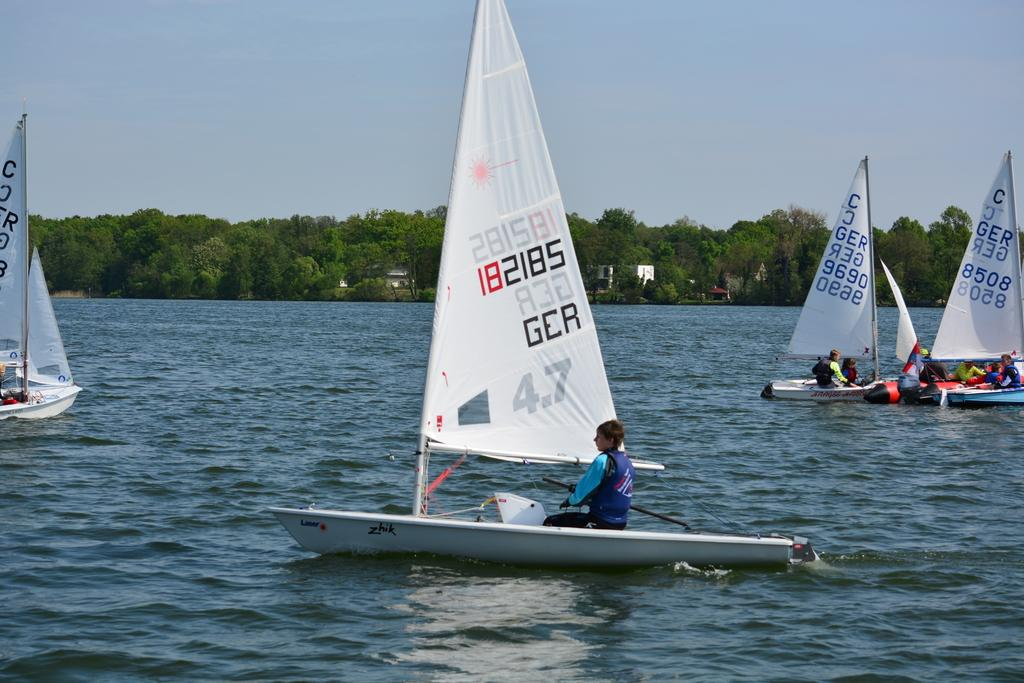What are the people in the image doing? The people in the image are sailing in a dinghy on the water. What can be seen in the background of the image? There are trees visible in the background of the image. What type of comb is being used by the people in the image? There is no comb present in the image; the people are sailing in a dinghy on the water. 